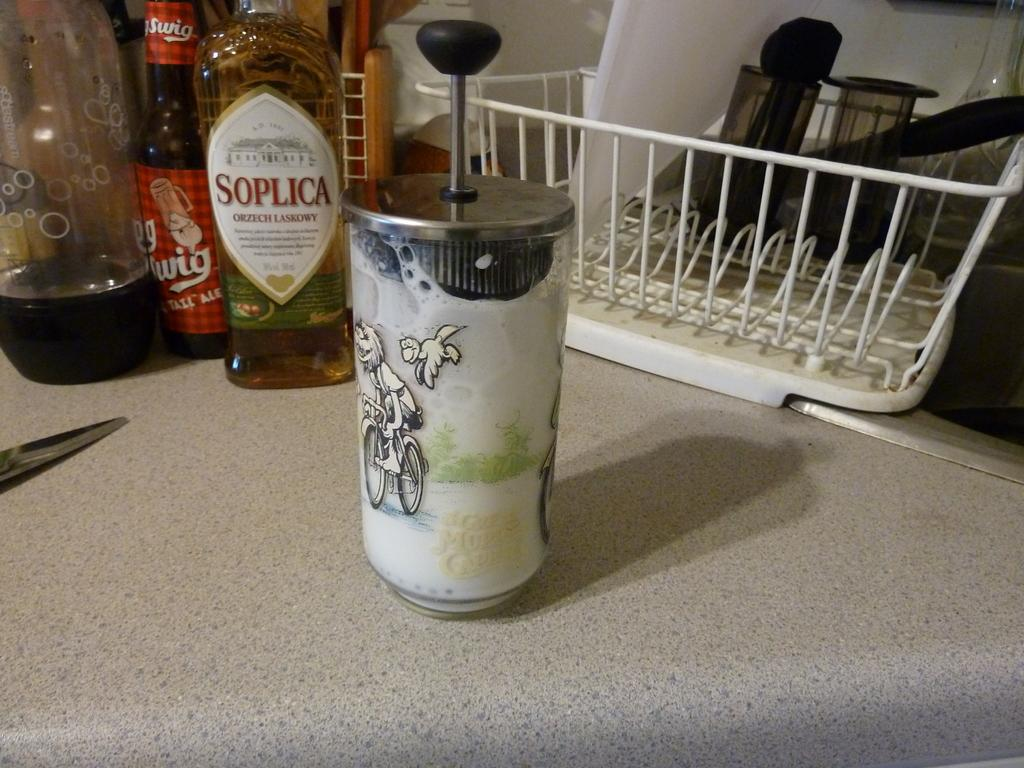<image>
Write a terse but informative summary of the picture. the word soplica is on the bottle that is clear 